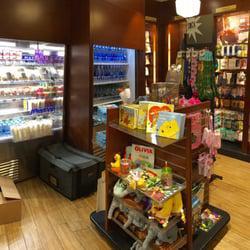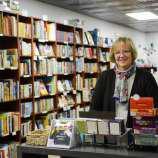The first image is the image on the left, the second image is the image on the right. Considering the images on both sides, is "The right image includes a person standing behind a counter that has three white squares in a row on it, and the wall near the counter is filled almost to the ceiling with books." valid? Answer yes or no. Yes. The first image is the image on the left, the second image is the image on the right. Considering the images on both sides, is "There are two people in dark shirts behind the counter of a bookstore," valid? Answer yes or no. No. 